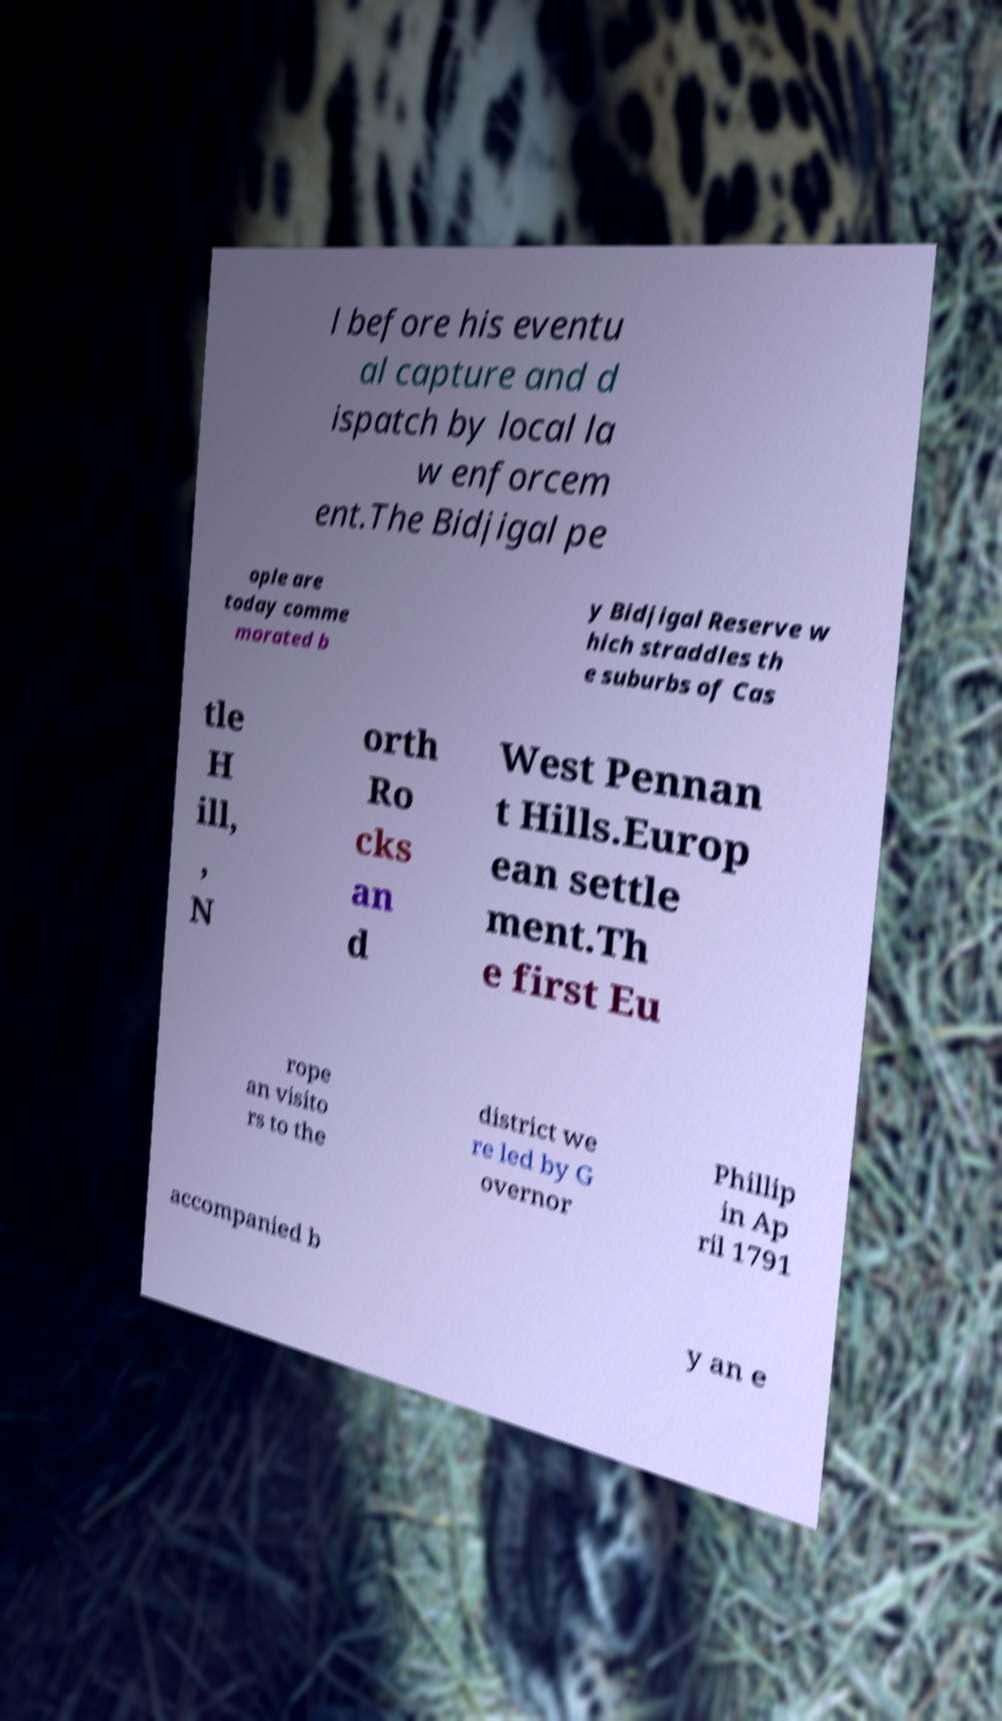Please read and relay the text visible in this image. What does it say? l before his eventu al capture and d ispatch by local la w enforcem ent.The Bidjigal pe ople are today comme morated b y Bidjigal Reserve w hich straddles th e suburbs of Cas tle H ill, , N orth Ro cks an d West Pennan t Hills.Europ ean settle ment.Th e first Eu rope an visito rs to the district we re led by G overnor Phillip in Ap ril 1791 accompanied b y an e 